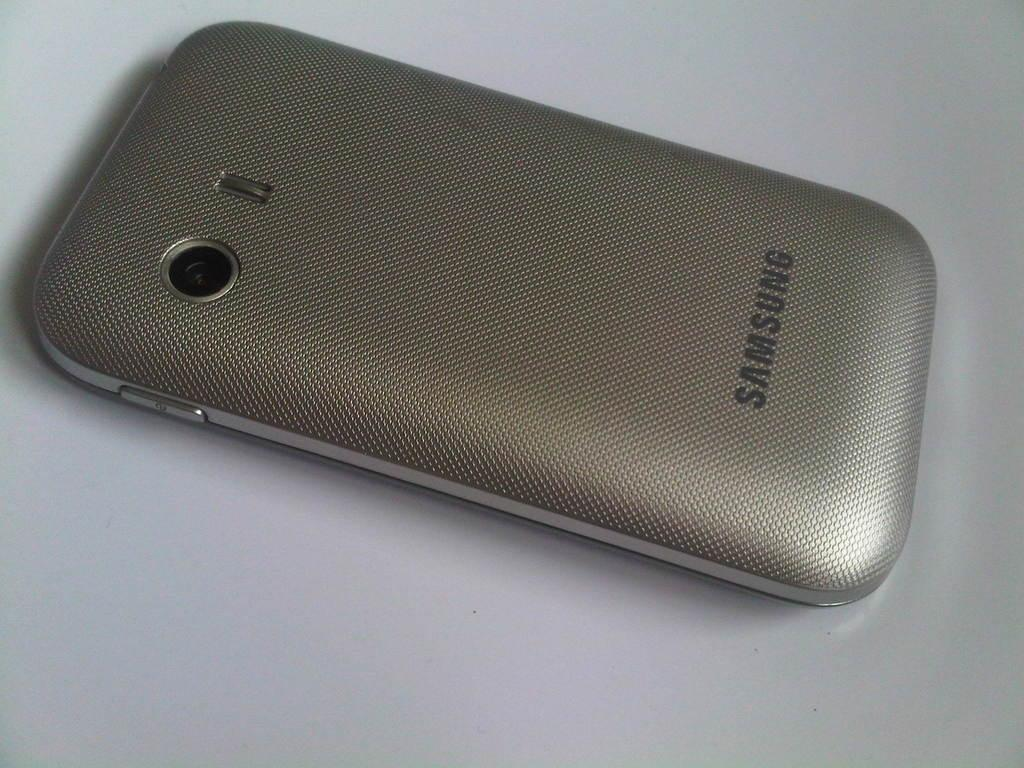<image>
Offer a succinct explanation of the picture presented. The back of a Samsung phone with the camera showing. 